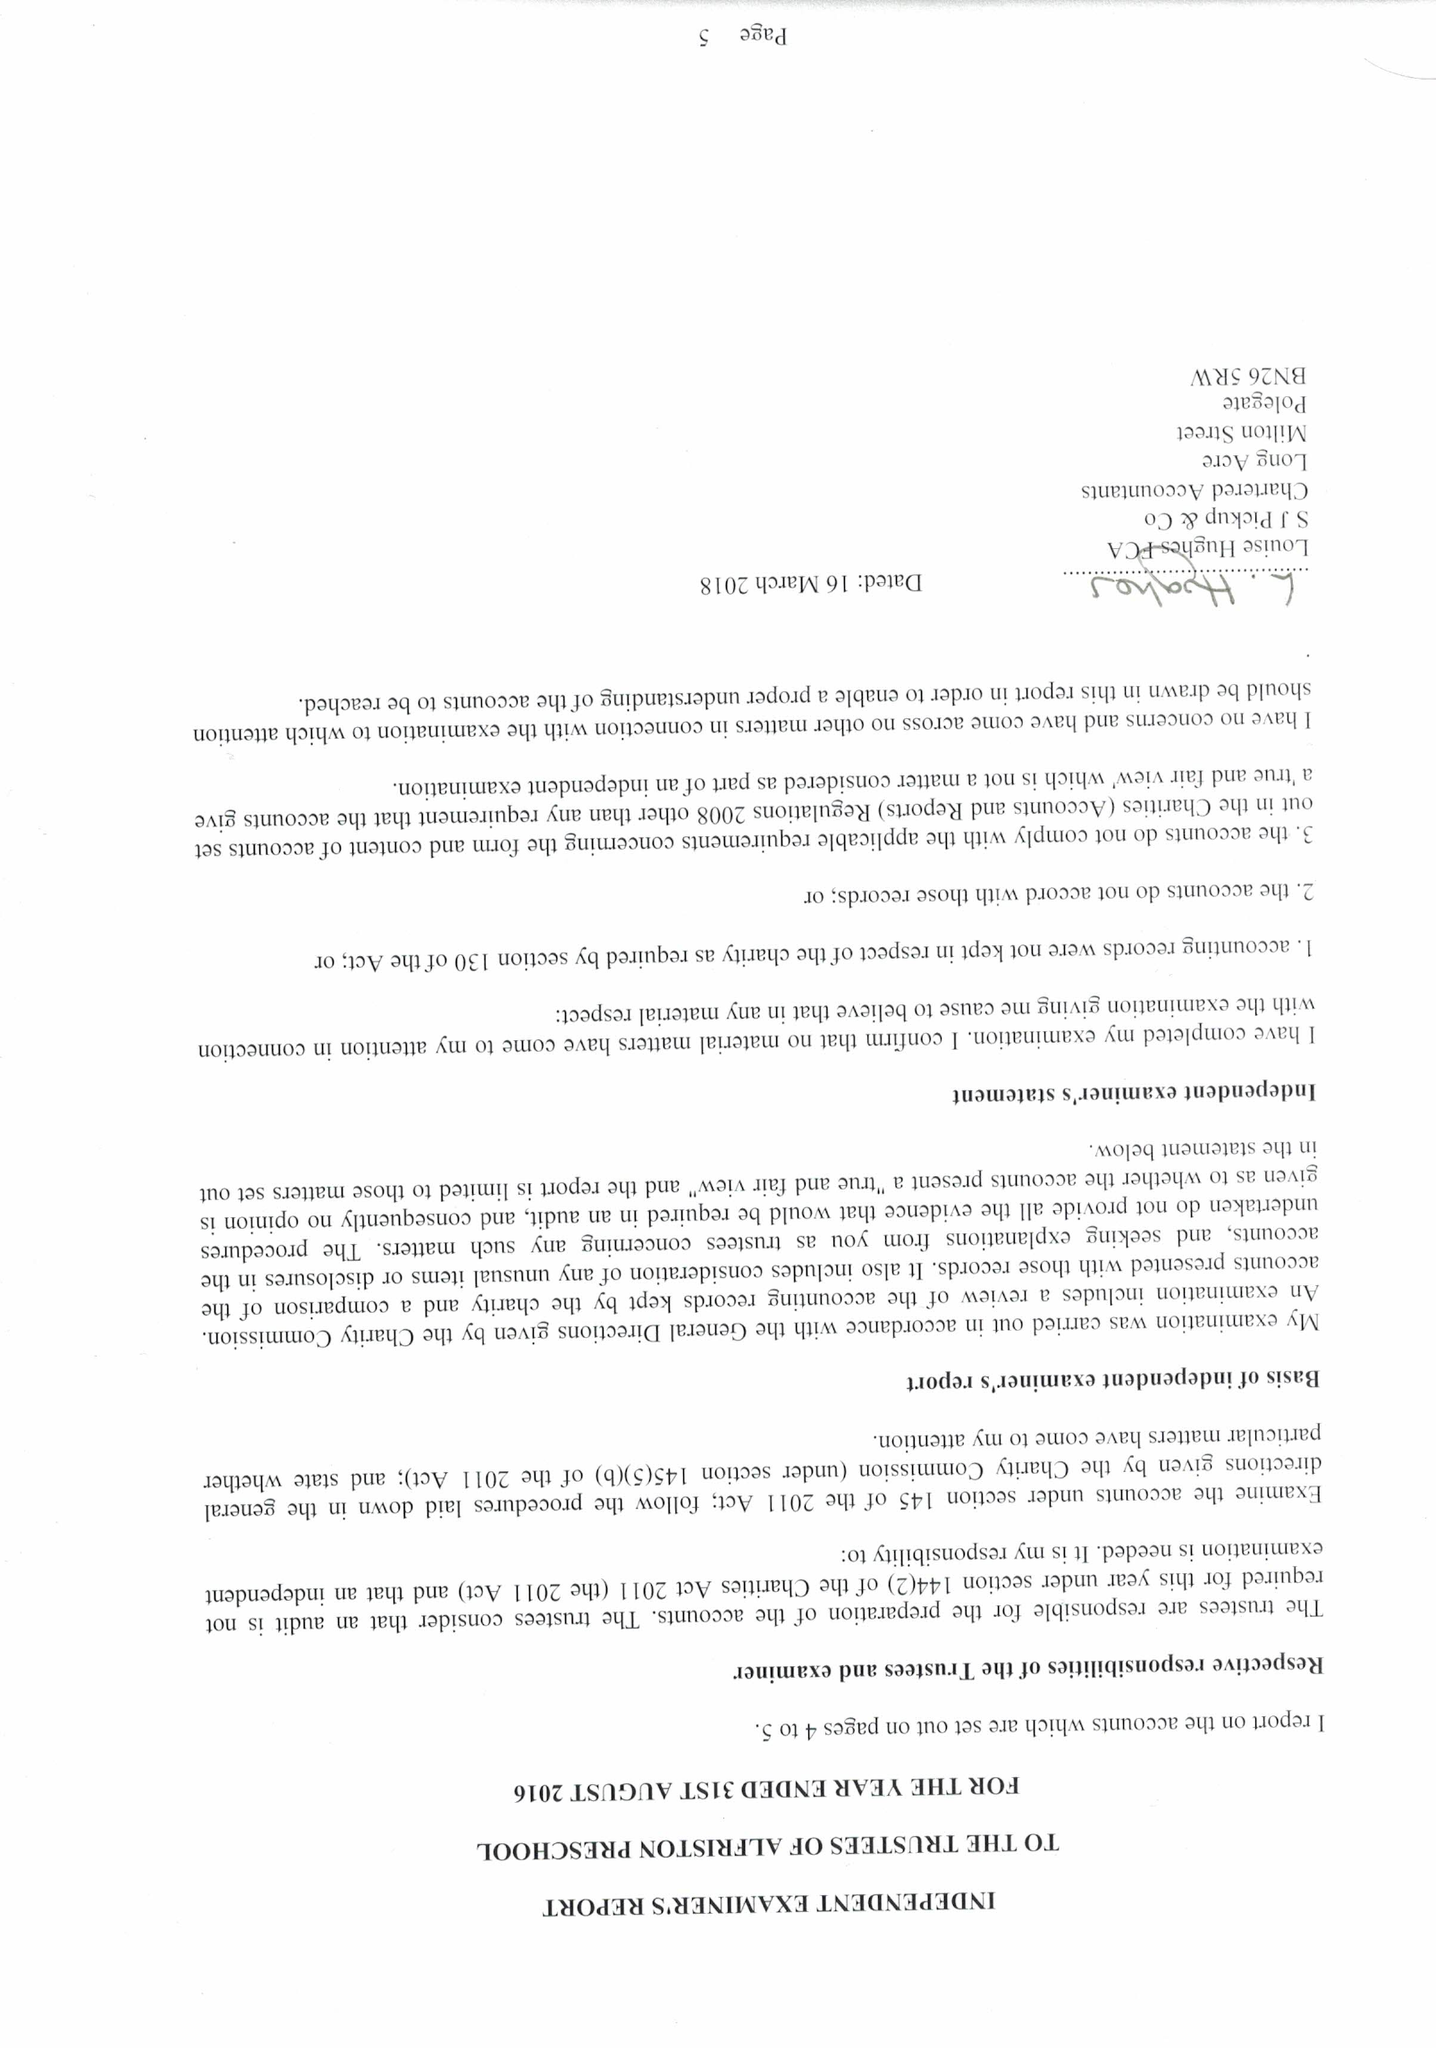What is the value for the address__post_town?
Answer the question using a single word or phrase. POLEGATE 